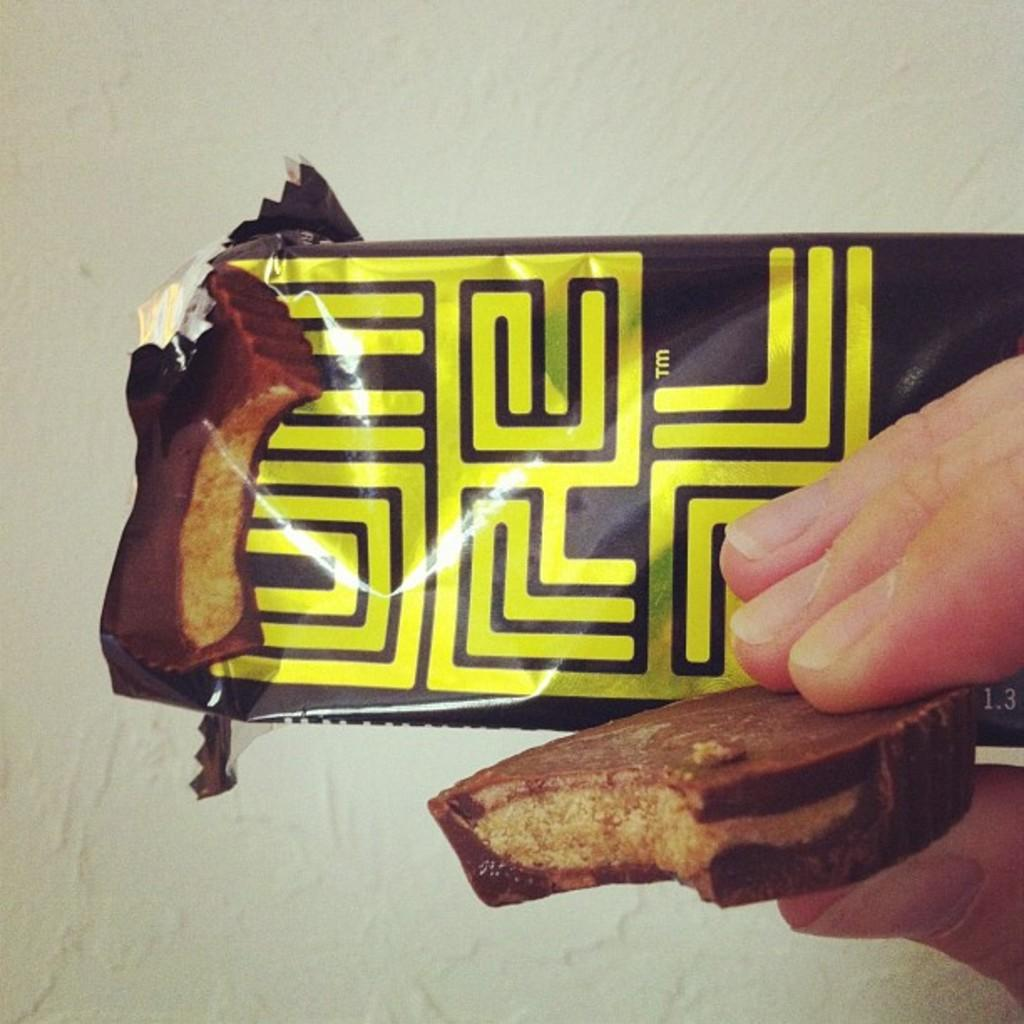What is the main object in the image? There is a cover in the image. What colors are used for the cover? The cover is in brown and yellow colors. What is the person in the image holding? There is a biscuit in the hand of a human in the image. What can be seen in the background of the image? There is a white wall in the background of the image. What type of record can be seen on the wall in the image? There is no record present on the wall in the image; it is a white wall without any visible records. 